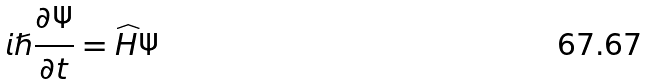<formula> <loc_0><loc_0><loc_500><loc_500>i \hslash \frac { \partial \Psi } { \partial t } = \widehat { H } \Psi</formula> 